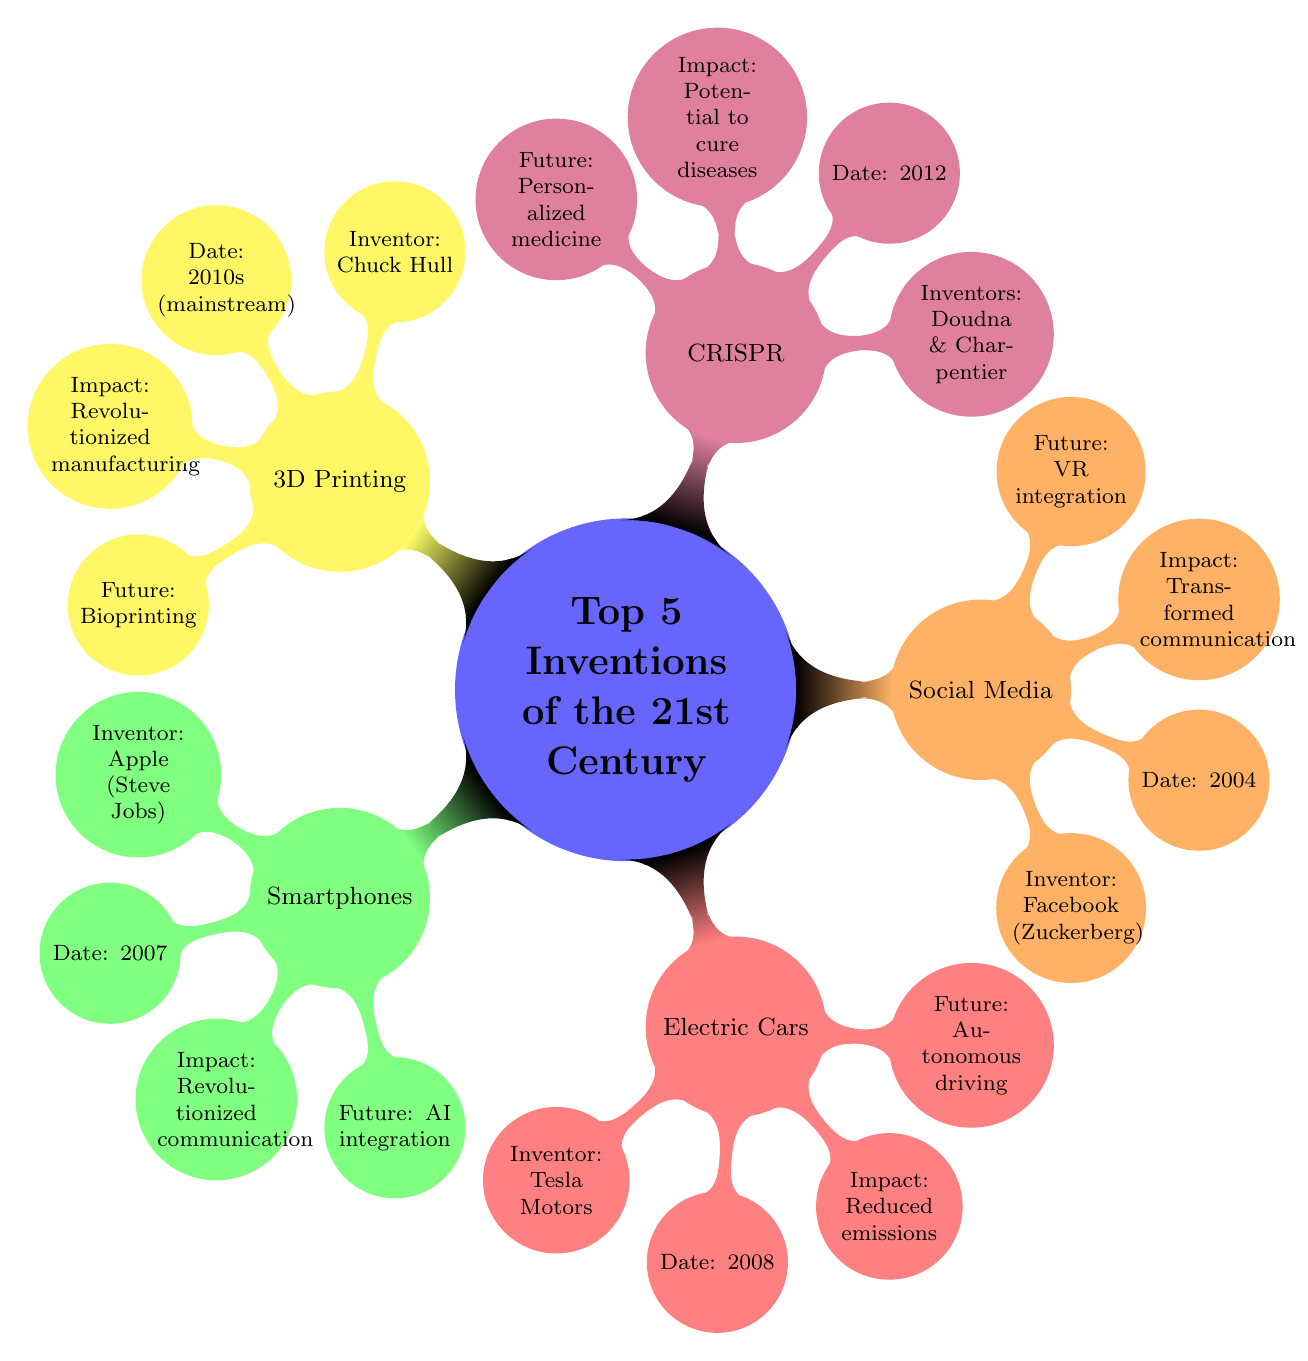What is the inventor of Social Media Platforms? The node for Social Media Platforms lists Facebook (Mark Zuckerberg) as the inventor. This information is directly seen within the corresponding child node of the Social Media section.
Answer: Facebook (Mark Zuckerberg) Which year were Electric Cars invented? The Electric Cars node specifies the date as 2008. This date is associated directly with the invention mentioned in that particular section of the diagram.
Answer: 2008 What impact did Smartphones have on society? The impact of Smartphones is noted in the diagram as "Revolutionized communication, access to information, and mobile computing." This impact is detailed within the corresponding child node under the Smartphones section.
Answer: Revolutionized communication, access to information, and mobile computing What is the future potential of CRISPR Gene Editing? The potential for CRISPR Gene Editing is labeled as "Personalized medicine, gene therapy advancements." This is indicated within a child node of the CRISPR section which outlines future possibilities.
Answer: Personalized medicine, gene therapy advancements Which invention was popularized in the 2010s? The 3D Printing node indicates that it was mainstreamed during the 2010s, highlighting the time frame in which it gained popularity. This detail can be found in its specific child node.
Answer: 2010s (mainstream) What are the future advancements expected for Electric Cars? The diagram states that the future potential for Electric Cars includes "Advancements in battery technology, autonomous driving." This information is detailed in the dedicated child node within the Electric Cars section.
Answer: Advancements in battery technology, autonomous driving Who invented 3D Printing? The node under the 3D Printing section shows Chuck Hull as the inventor. The reference to the inventor is clearly marked in the corresponding child node.
Answer: Chuck Hull What transformed human communication? The impact of Social Media Platforms is specified in the diagram as having "Transformed human communication." This is directly seen in the impact node under the Social Media section.
Answer: Transformed human communication What year was CRISPR Gene Editing invented? The diagram denotes the year of CRISPR's invention as 2012. This information can be easily sourced from the corresponding date node in the CRISPR section.
Answer: 2012 